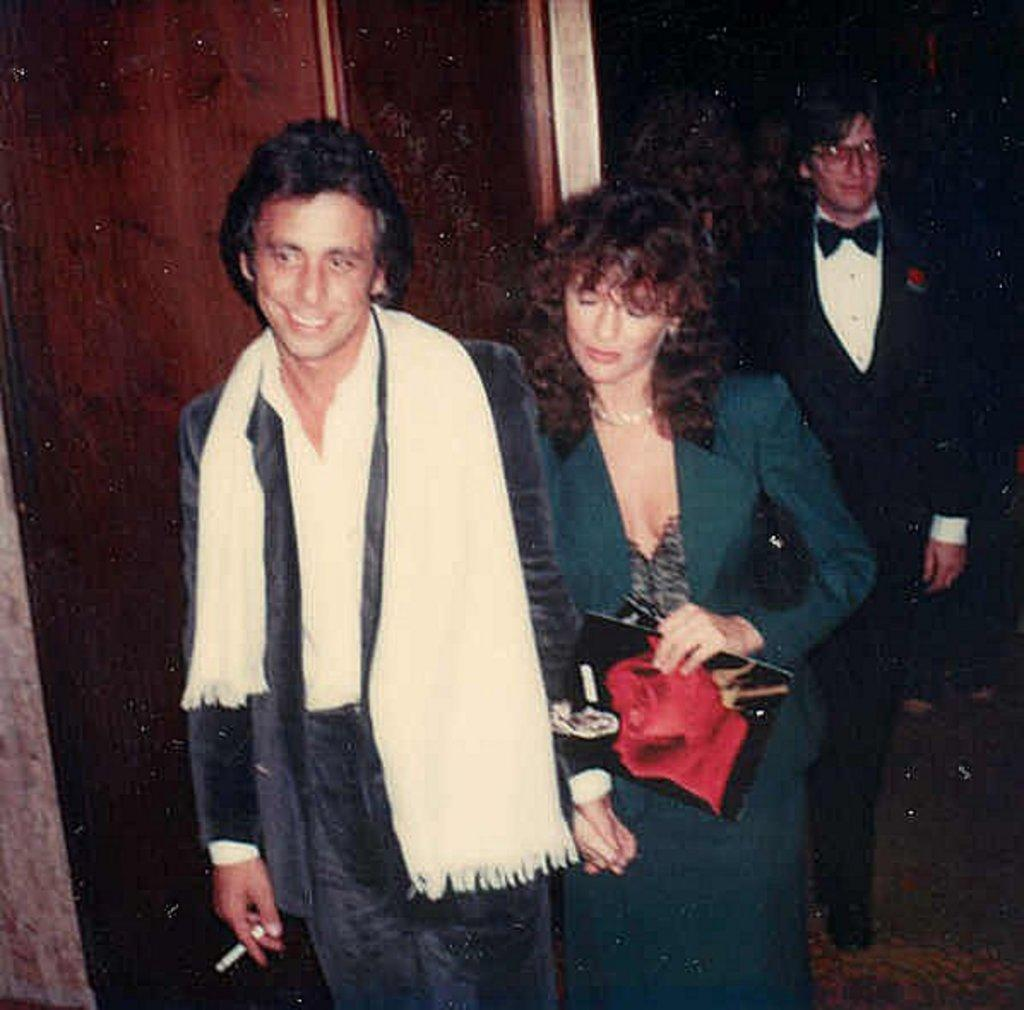How many people are in the image? There is a group of people in the image. What are the people doing in the image? The people are standing on the floor. Can you describe any specific actions or objects held by the people? One woman is holding a book in her hand. What can be seen in the background of the image? There is a wall visible in the background of the image. Are the people in the image riding bikes? There is no indication in the image that the people are riding bikes; they are standing on the floor. 